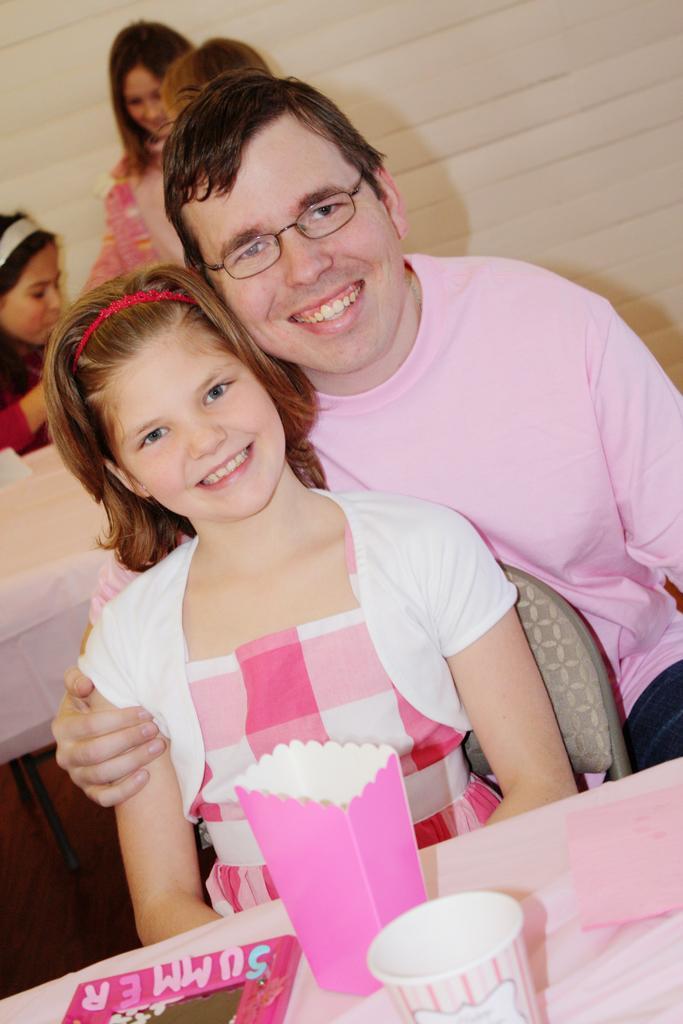How would you summarize this image in a sentence or two? In this image we can see three people are sitting on the chairs, two tables covered with table cloth, two women are standing, some objects are on the table and backside of these people there is a white wall. 